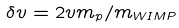<formula> <loc_0><loc_0><loc_500><loc_500>\delta v = 2 v m _ { p } / m _ { W I M P }</formula> 